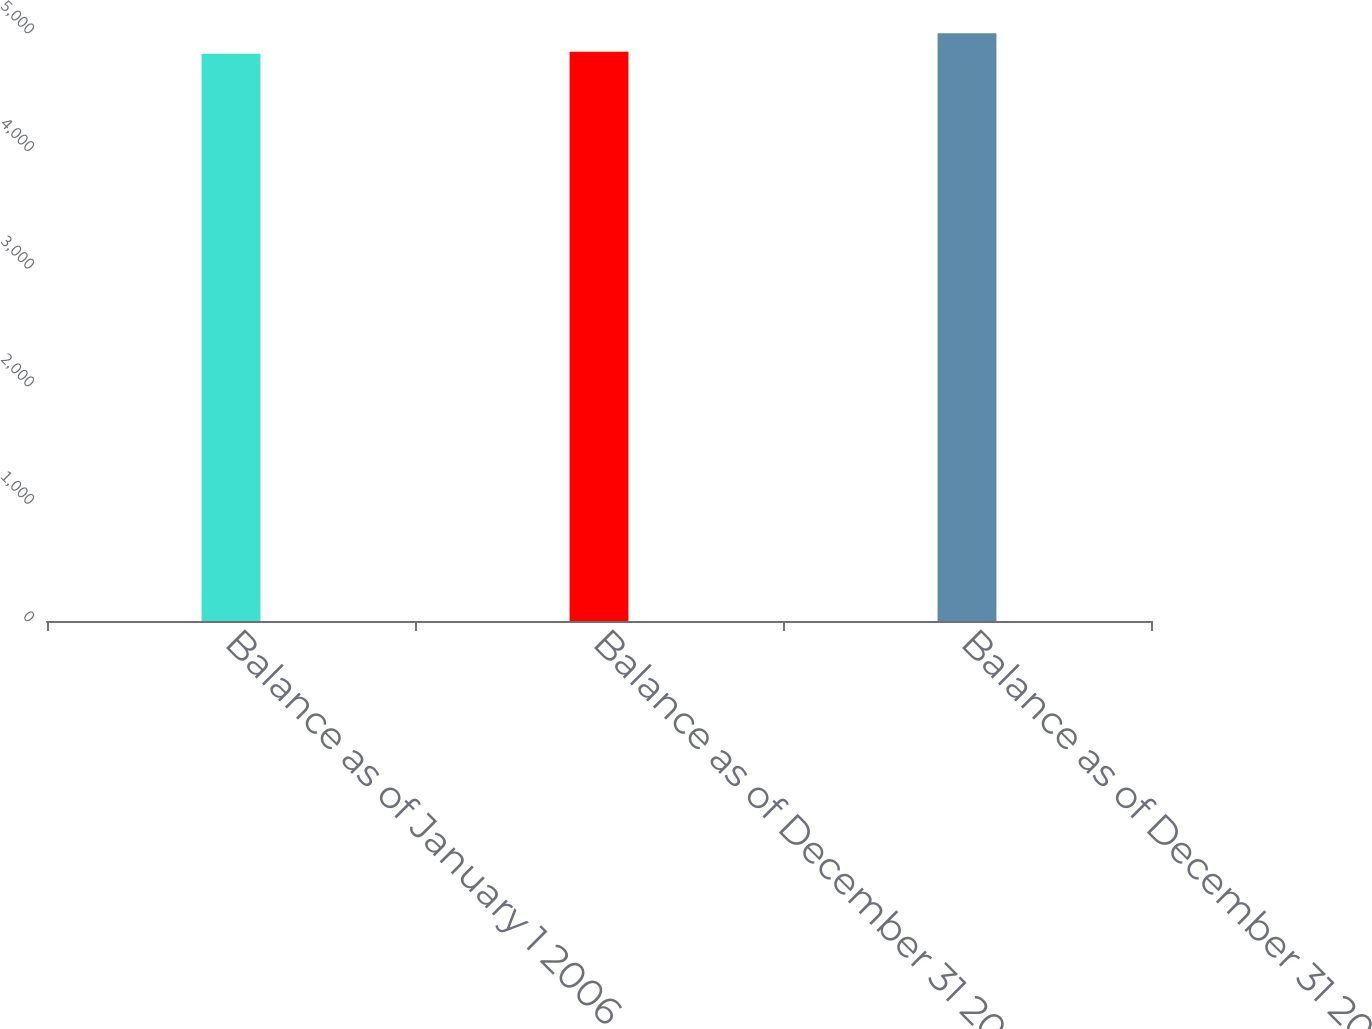<chart> <loc_0><loc_0><loc_500><loc_500><bar_chart><fcel>Balance as of January 1 2006<fcel>Balance as of December 31 2006<fcel>Balance as of December 31 2007<nl><fcel>4823<fcel>4840.5<fcel>4998<nl></chart> 